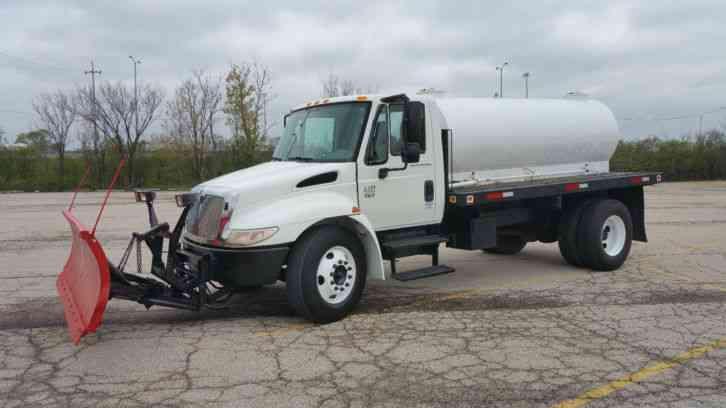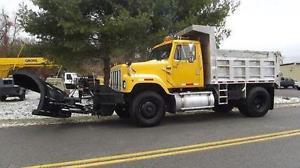The first image is the image on the left, the second image is the image on the right. Examine the images to the left and right. Is the description "An image shows a leftward-facing truck with a bright yellow plow." accurate? Answer yes or no. No. 